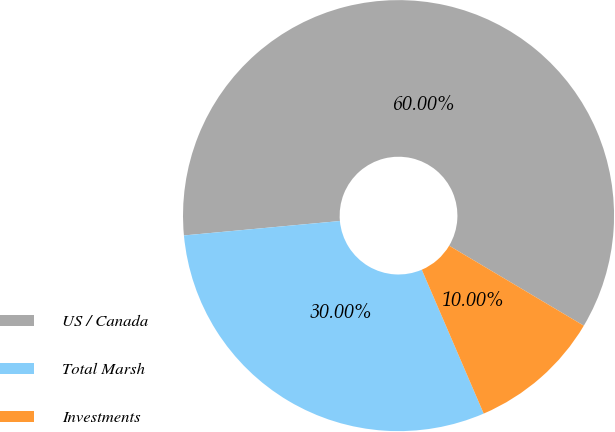Convert chart to OTSL. <chart><loc_0><loc_0><loc_500><loc_500><pie_chart><fcel>US / Canada<fcel>Total Marsh<fcel>Investments<nl><fcel>60.0%<fcel>30.0%<fcel>10.0%<nl></chart> 